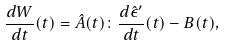Convert formula to latex. <formula><loc_0><loc_0><loc_500><loc_500>\frac { d W } { d t } ( t ) = \hat { A } ( t ) \colon \frac { d \hat { \epsilon } ^ { \prime } } { d t } ( t ) - B ( t ) ,</formula> 